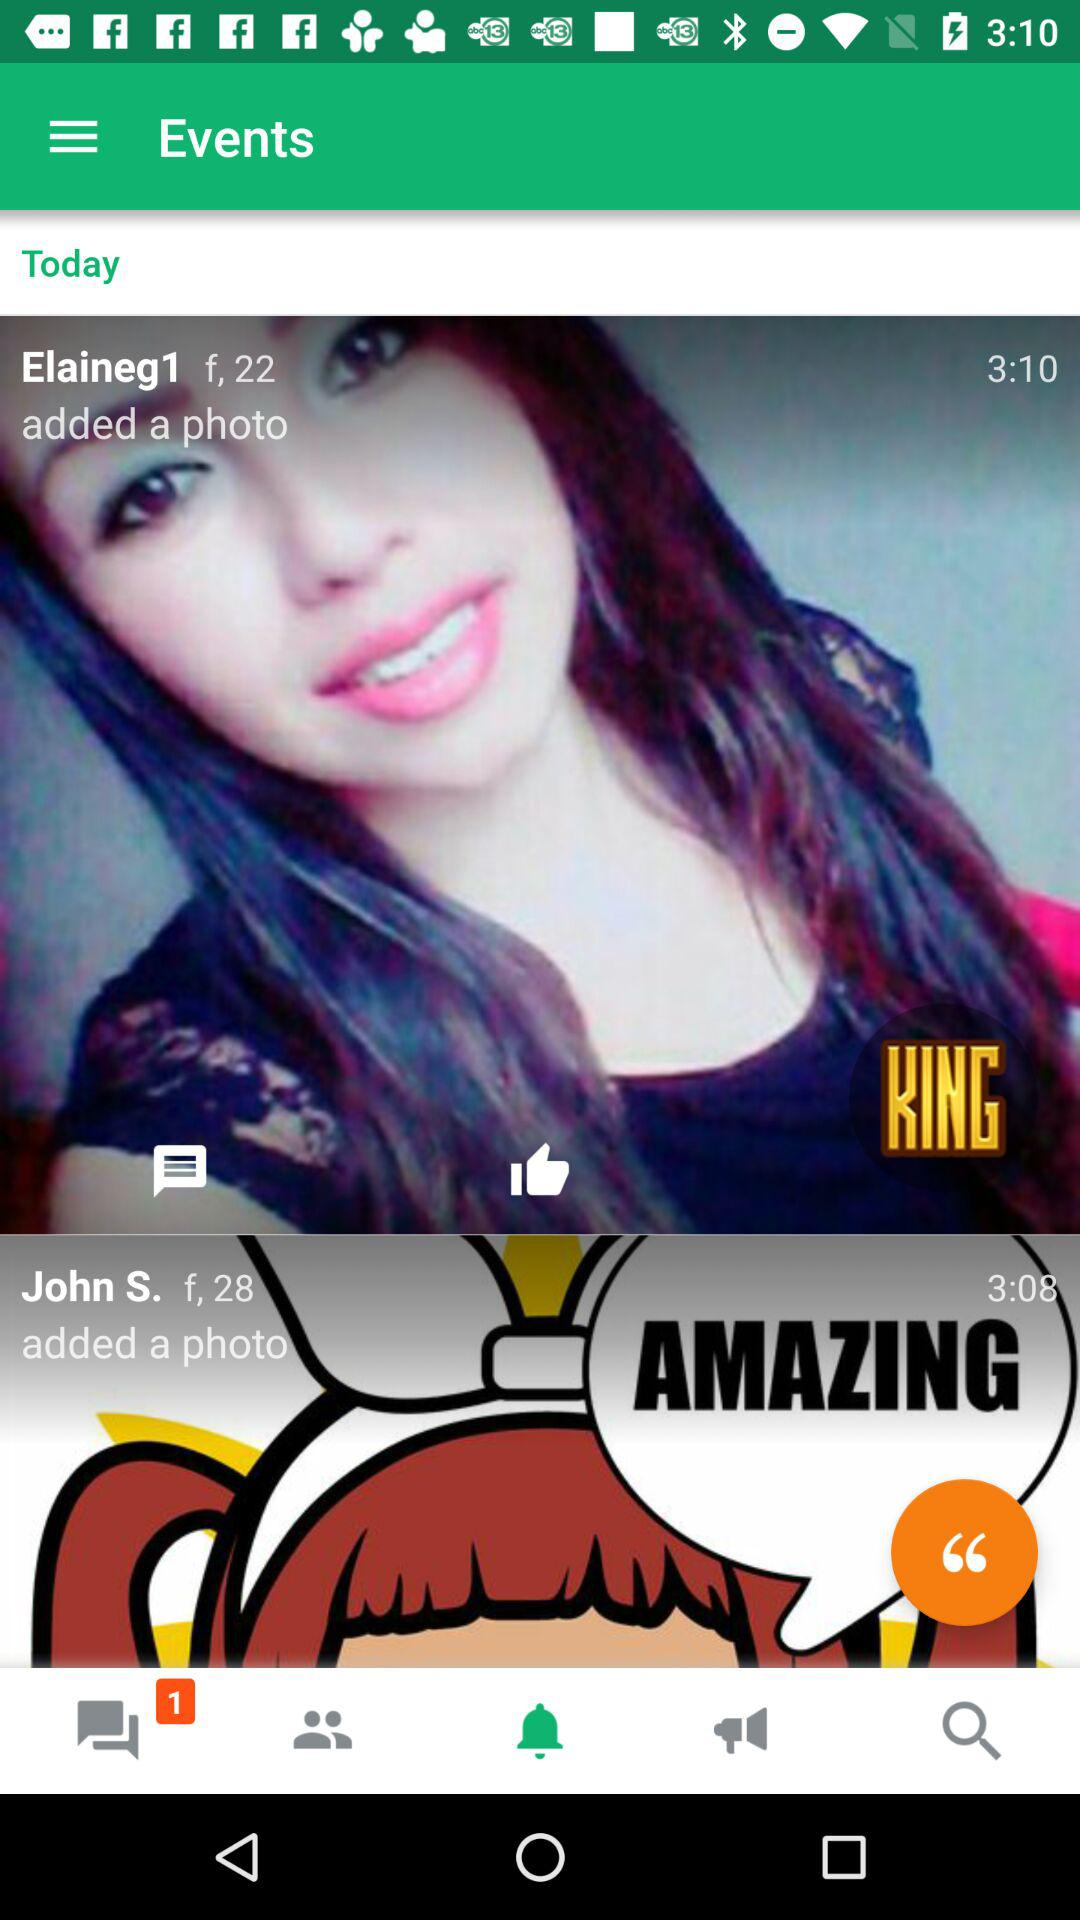At what time did "Elaineg1" add a photo? "Elaineg1" added a photo at 3:10. 